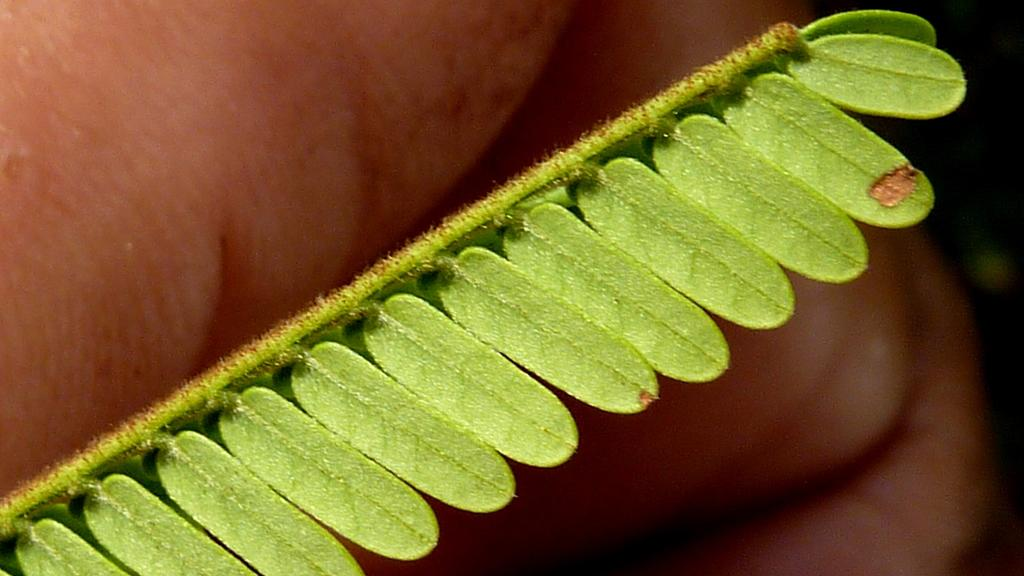What is the main subject of the image? The main subject of the image is a stem. What can be observed about the stem in the image? The stem has leaves. What type of calendar is hanging from the stem in the image? There is no calendar present in the image; it only features a stem with leaves. What type of teeth can be seen on the stem in the image? There are no teeth present in the image, as the stem is a part of a plant and plants do not have teeth. 